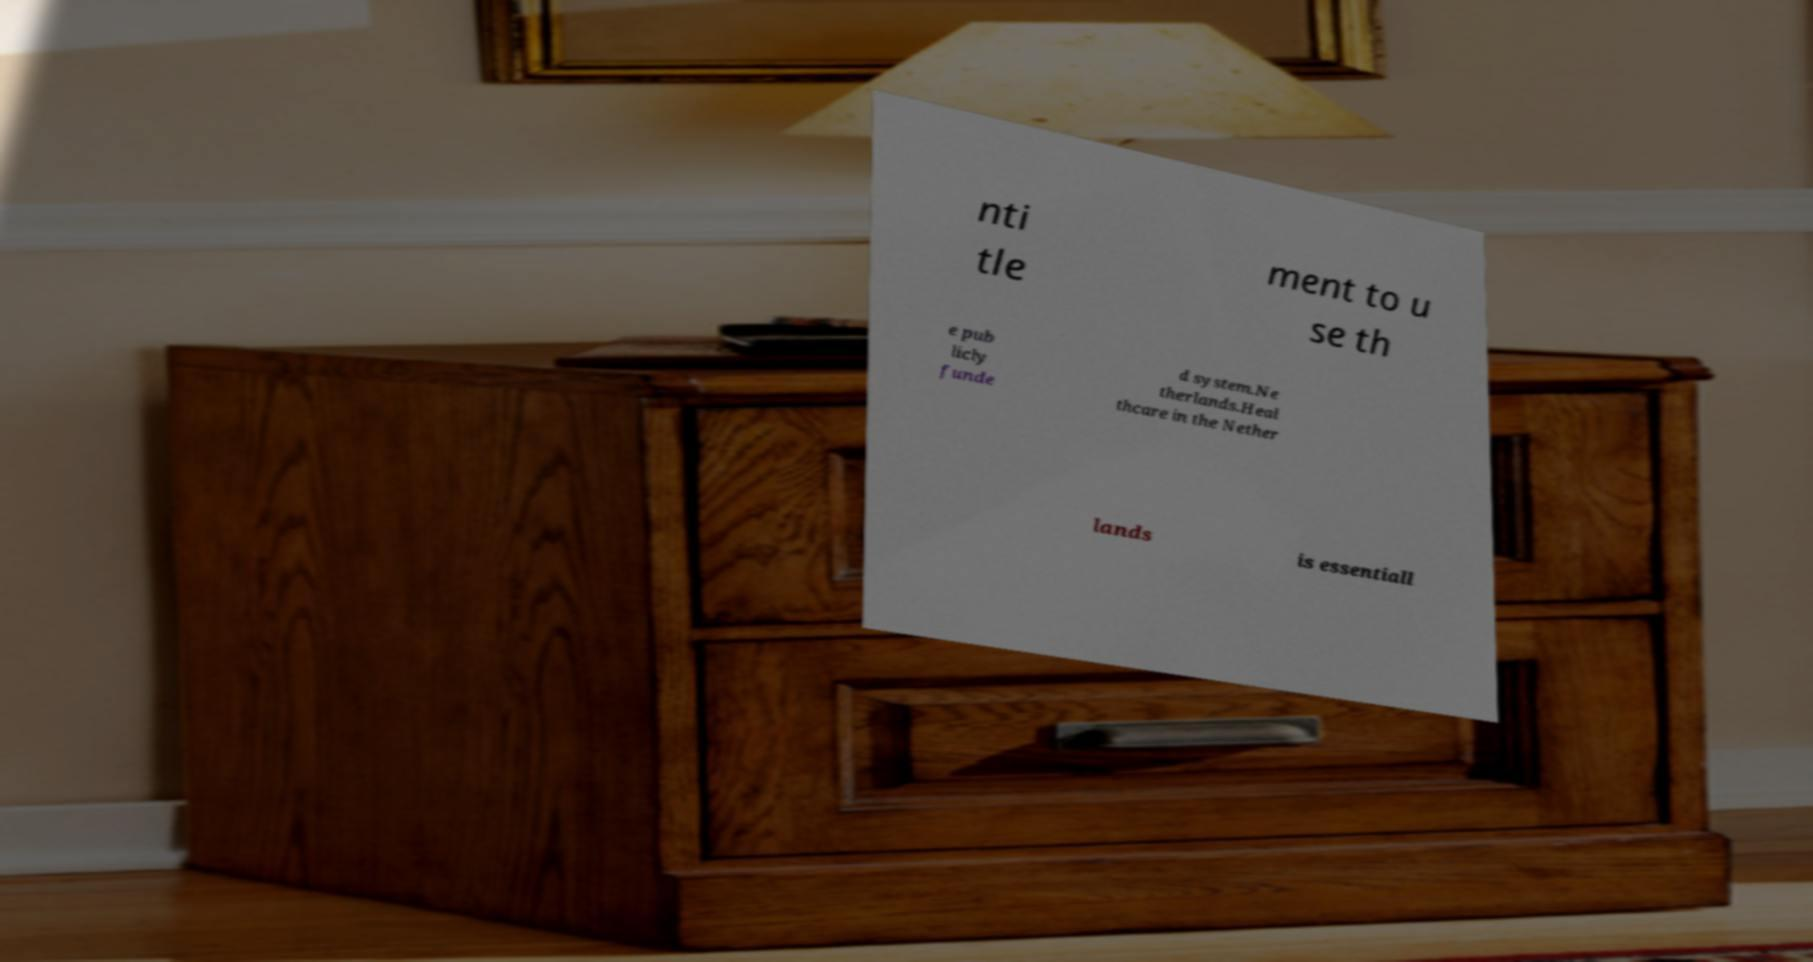Please identify and transcribe the text found in this image. nti tle ment to u se th e pub licly funde d system.Ne therlands.Heal thcare in the Nether lands is essentiall 